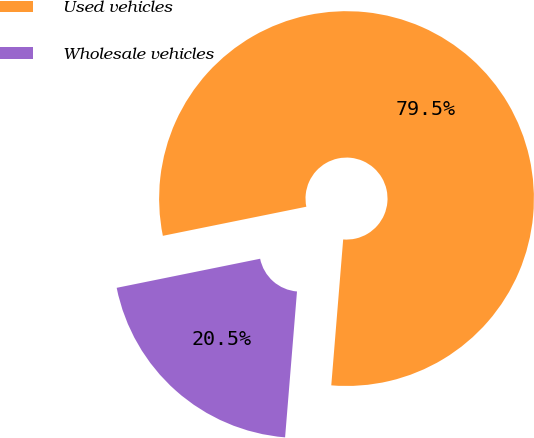<chart> <loc_0><loc_0><loc_500><loc_500><pie_chart><fcel>Used vehicles<fcel>Wholesale vehicles<nl><fcel>79.48%<fcel>20.52%<nl></chart> 